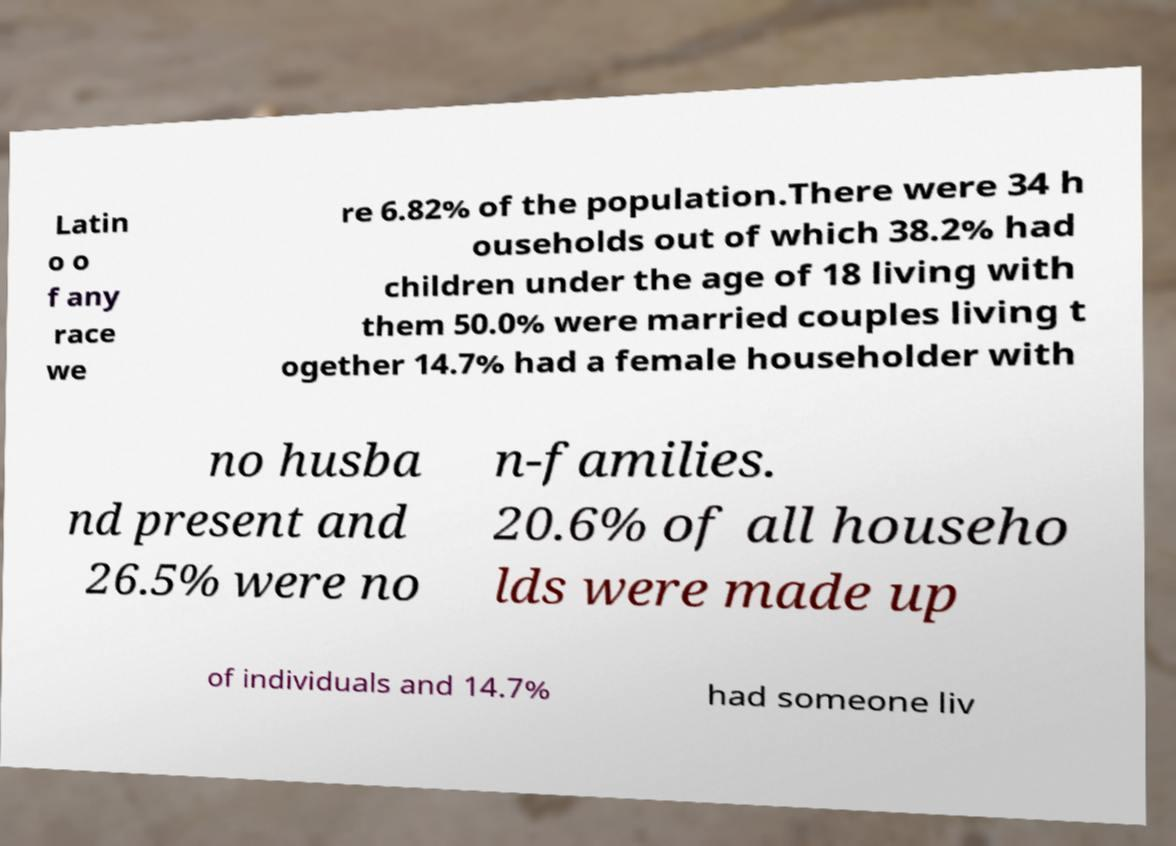Please identify and transcribe the text found in this image. Latin o o f any race we re 6.82% of the population.There were 34 h ouseholds out of which 38.2% had children under the age of 18 living with them 50.0% were married couples living t ogether 14.7% had a female householder with no husba nd present and 26.5% were no n-families. 20.6% of all househo lds were made up of individuals and 14.7% had someone liv 